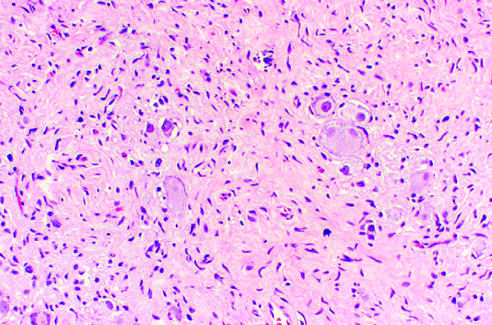re infants who survive presented in the background stroma?
Answer the question using a single word or phrase. No 